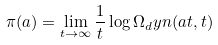Convert formula to latex. <formula><loc_0><loc_0><loc_500><loc_500>\pi ( a ) = \lim _ { t \to \infty } \frac { 1 } { t } \log \Omega _ { d } y n ( a t , t )</formula> 